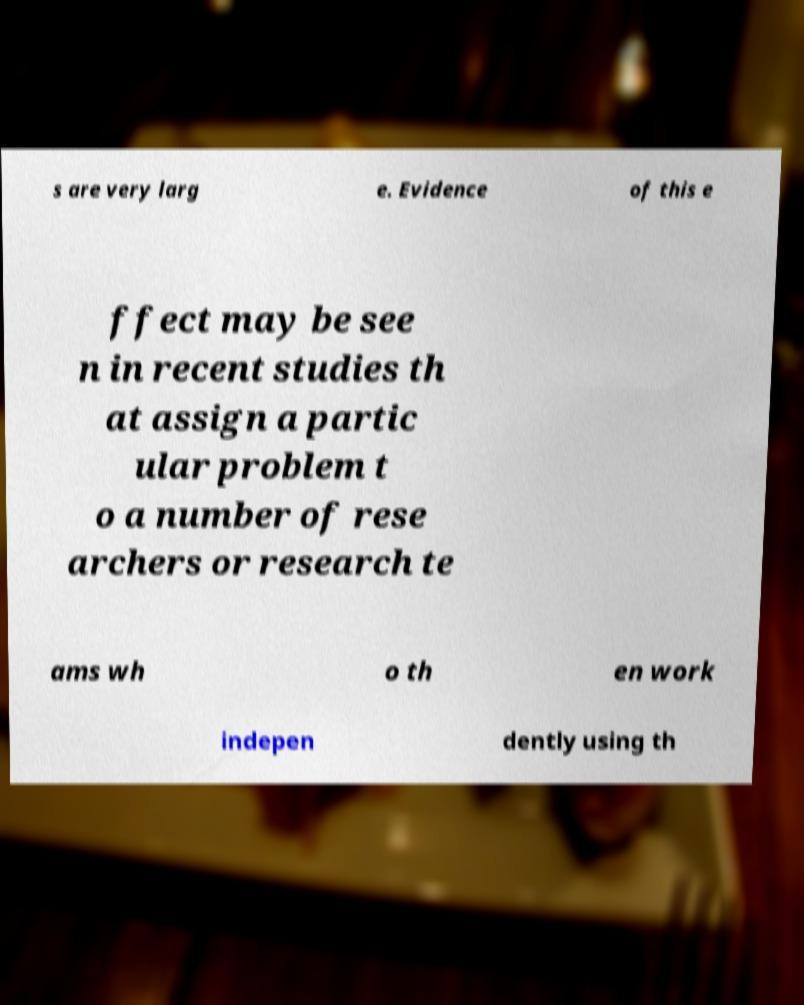I need the written content from this picture converted into text. Can you do that? s are very larg e. Evidence of this e ffect may be see n in recent studies th at assign a partic ular problem t o a number of rese archers or research te ams wh o th en work indepen dently using th 